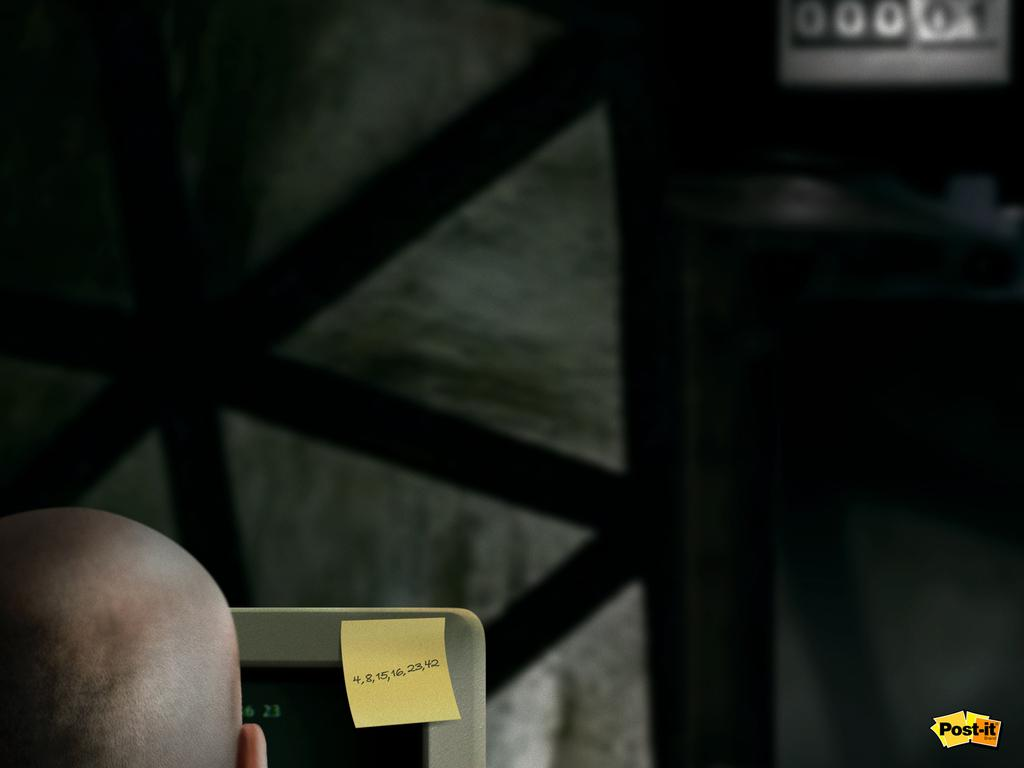What is the main subject of the image? There is a man in the image. What object is the man using in the image? There is a laptop in the image. What can be seen in the background of the image? There is a wall in the image. What type of fruit is the man holding in the image? There is no fruit present in the image; the man is using a laptop. Who is the man talking to in the image? The image does not show the man talking to anyone, so it cannot be determined from the image. 